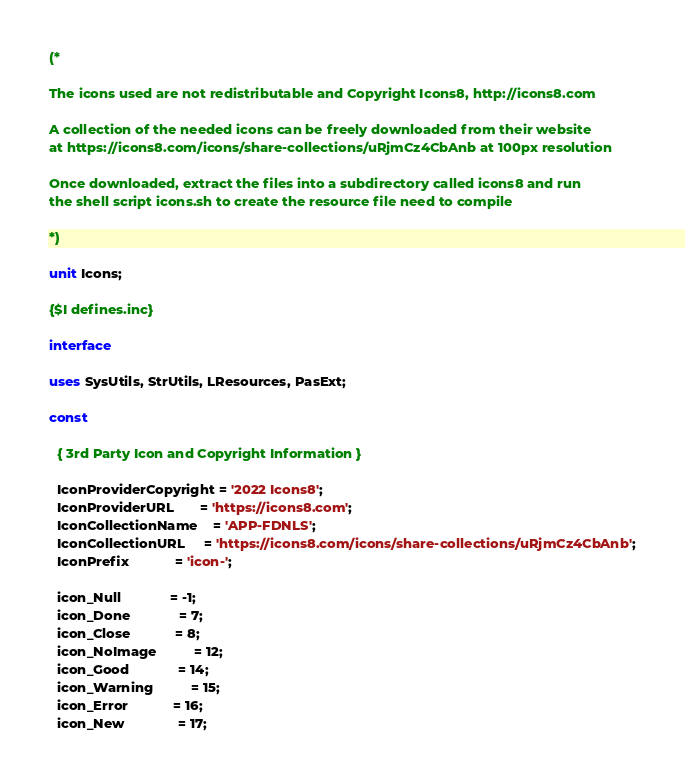<code> <loc_0><loc_0><loc_500><loc_500><_Pascal_>(*

The icons used are not redistributable and Copyright Icons8, http://icons8.com

A collection of the needed icons can be freely downloaded from their website
at https://icons8.com/icons/share-collections/uRjmCz4CbAnb at 100px resolution

Once downloaded, extract the files into a subdirectory called icons8 and run
the shell script icons.sh to create the resource file need to compile

*)

unit Icons;

{$I defines.inc}

interface

uses SysUtils, StrUtils, LResources, PasExt;

const

  { 3rd Party Icon and Copyright Information }

  IconProviderCopyright = '2022 Icons8';
  IconProviderURL       = 'https://icons8.com';
  IconCollectionName    = 'APP-FDNLS';
  IconCollectionURL     = 'https://icons8.com/icons/share-collections/uRjmCz4CbAnb';
  IconPrefix            = 'icon-';

  icon_Null             = -1;
  icon_Done             = 7;
  icon_Close            = 8;
  icon_NoImage          = 12;
  icon_Good             = 14;
  icon_Warning          = 15;
  icon_Error            = 16;
  icon_New              = 17;

</code> 